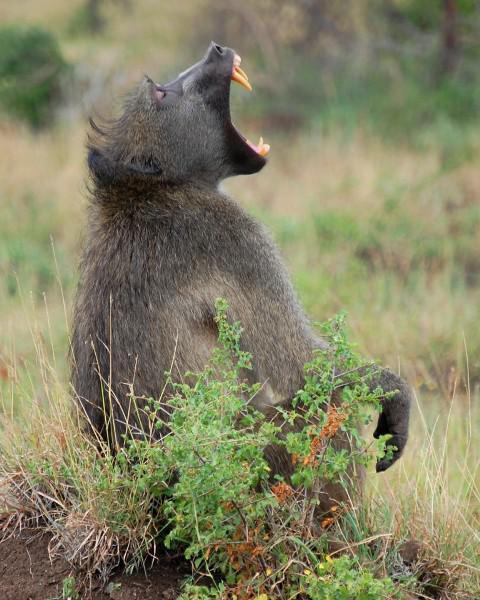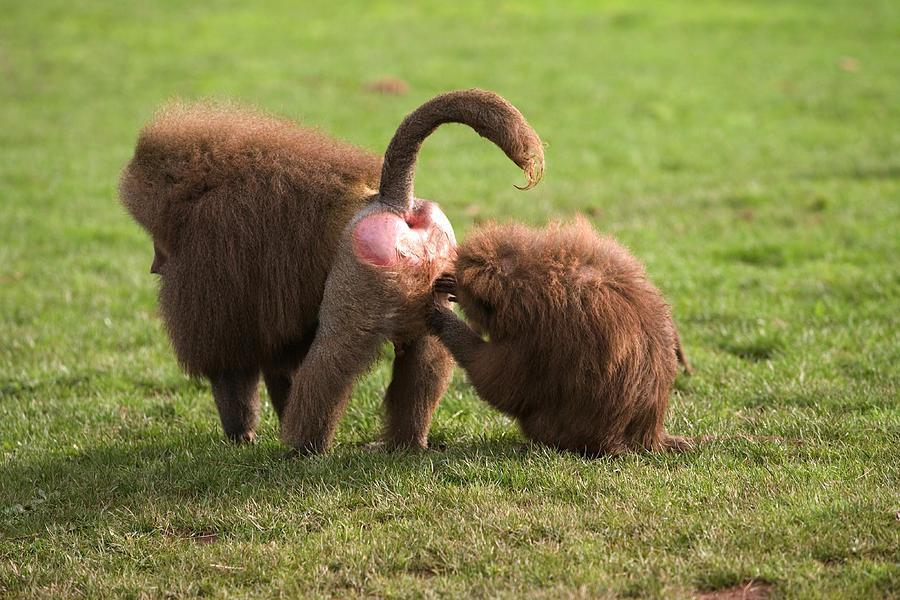The first image is the image on the left, the second image is the image on the right. For the images shown, is this caption "There is a single animal in the image on the right baring its teeth." true? Answer yes or no. No. 